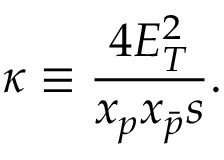Convert formula to latex. <formula><loc_0><loc_0><loc_500><loc_500>\kappa \equiv \frac { 4 E _ { T } ^ { 2 } } { x _ { p } x _ { \bar { p } } s } .</formula> 